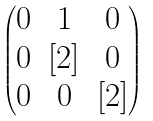Convert formula to latex. <formula><loc_0><loc_0><loc_500><loc_500>\begin{pmatrix} 0 & 1 & 0 \\ 0 & [ 2 ] & 0 \\ 0 & 0 & [ 2 ] \end{pmatrix}</formula> 